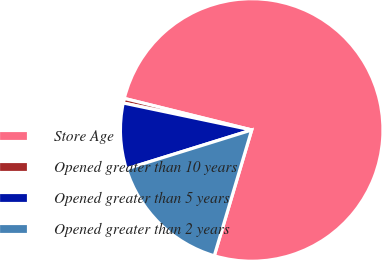<chart> <loc_0><loc_0><loc_500><loc_500><pie_chart><fcel>Store Age<fcel>Opened greater than 10 years<fcel>Opened greater than 5 years<fcel>Opened greater than 2 years<nl><fcel>75.73%<fcel>0.57%<fcel>8.09%<fcel>15.6%<nl></chart> 